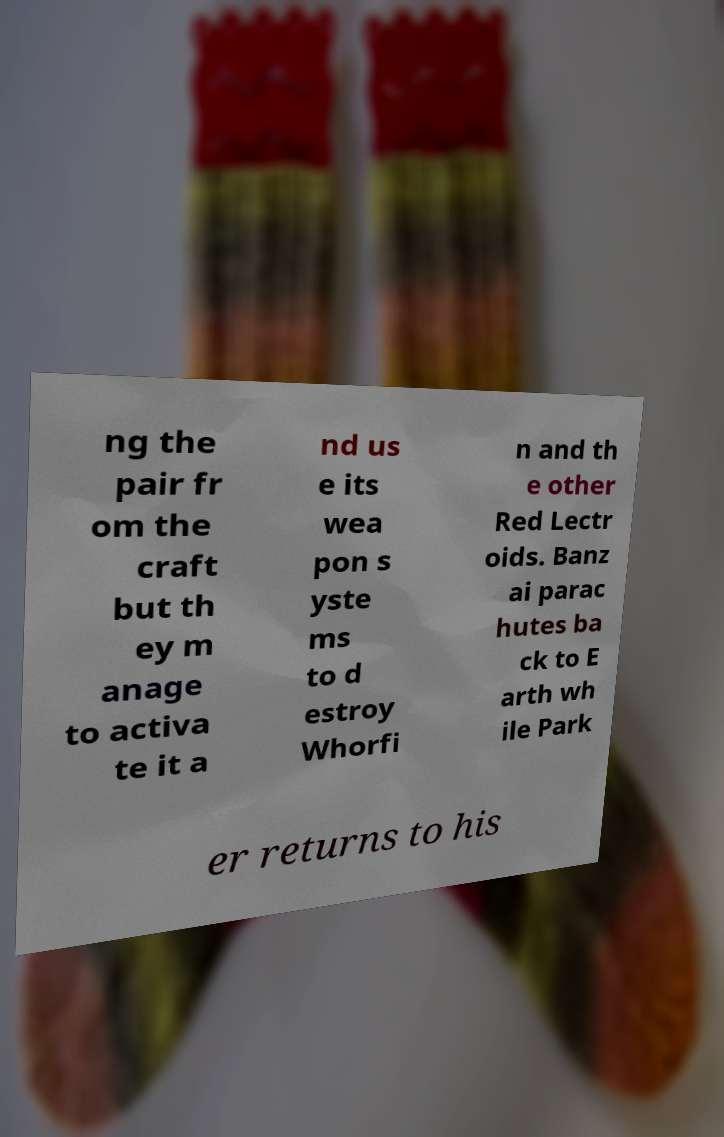Can you read and provide the text displayed in the image?This photo seems to have some interesting text. Can you extract and type it out for me? ng the pair fr om the craft but th ey m anage to activa te it a nd us e its wea pon s yste ms to d estroy Whorfi n and th e other Red Lectr oids. Banz ai parac hutes ba ck to E arth wh ile Park er returns to his 